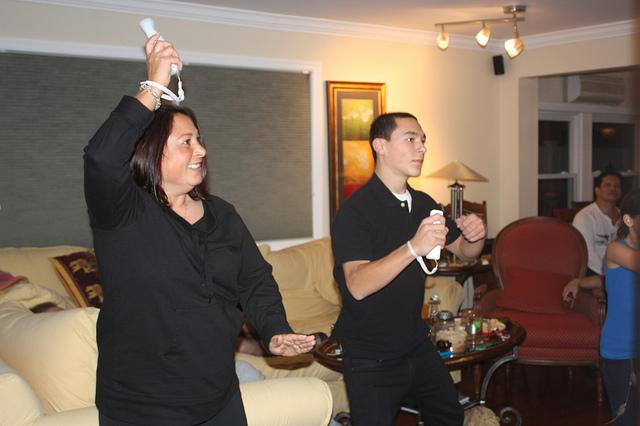The relationship between these people is most likely what? parent child 